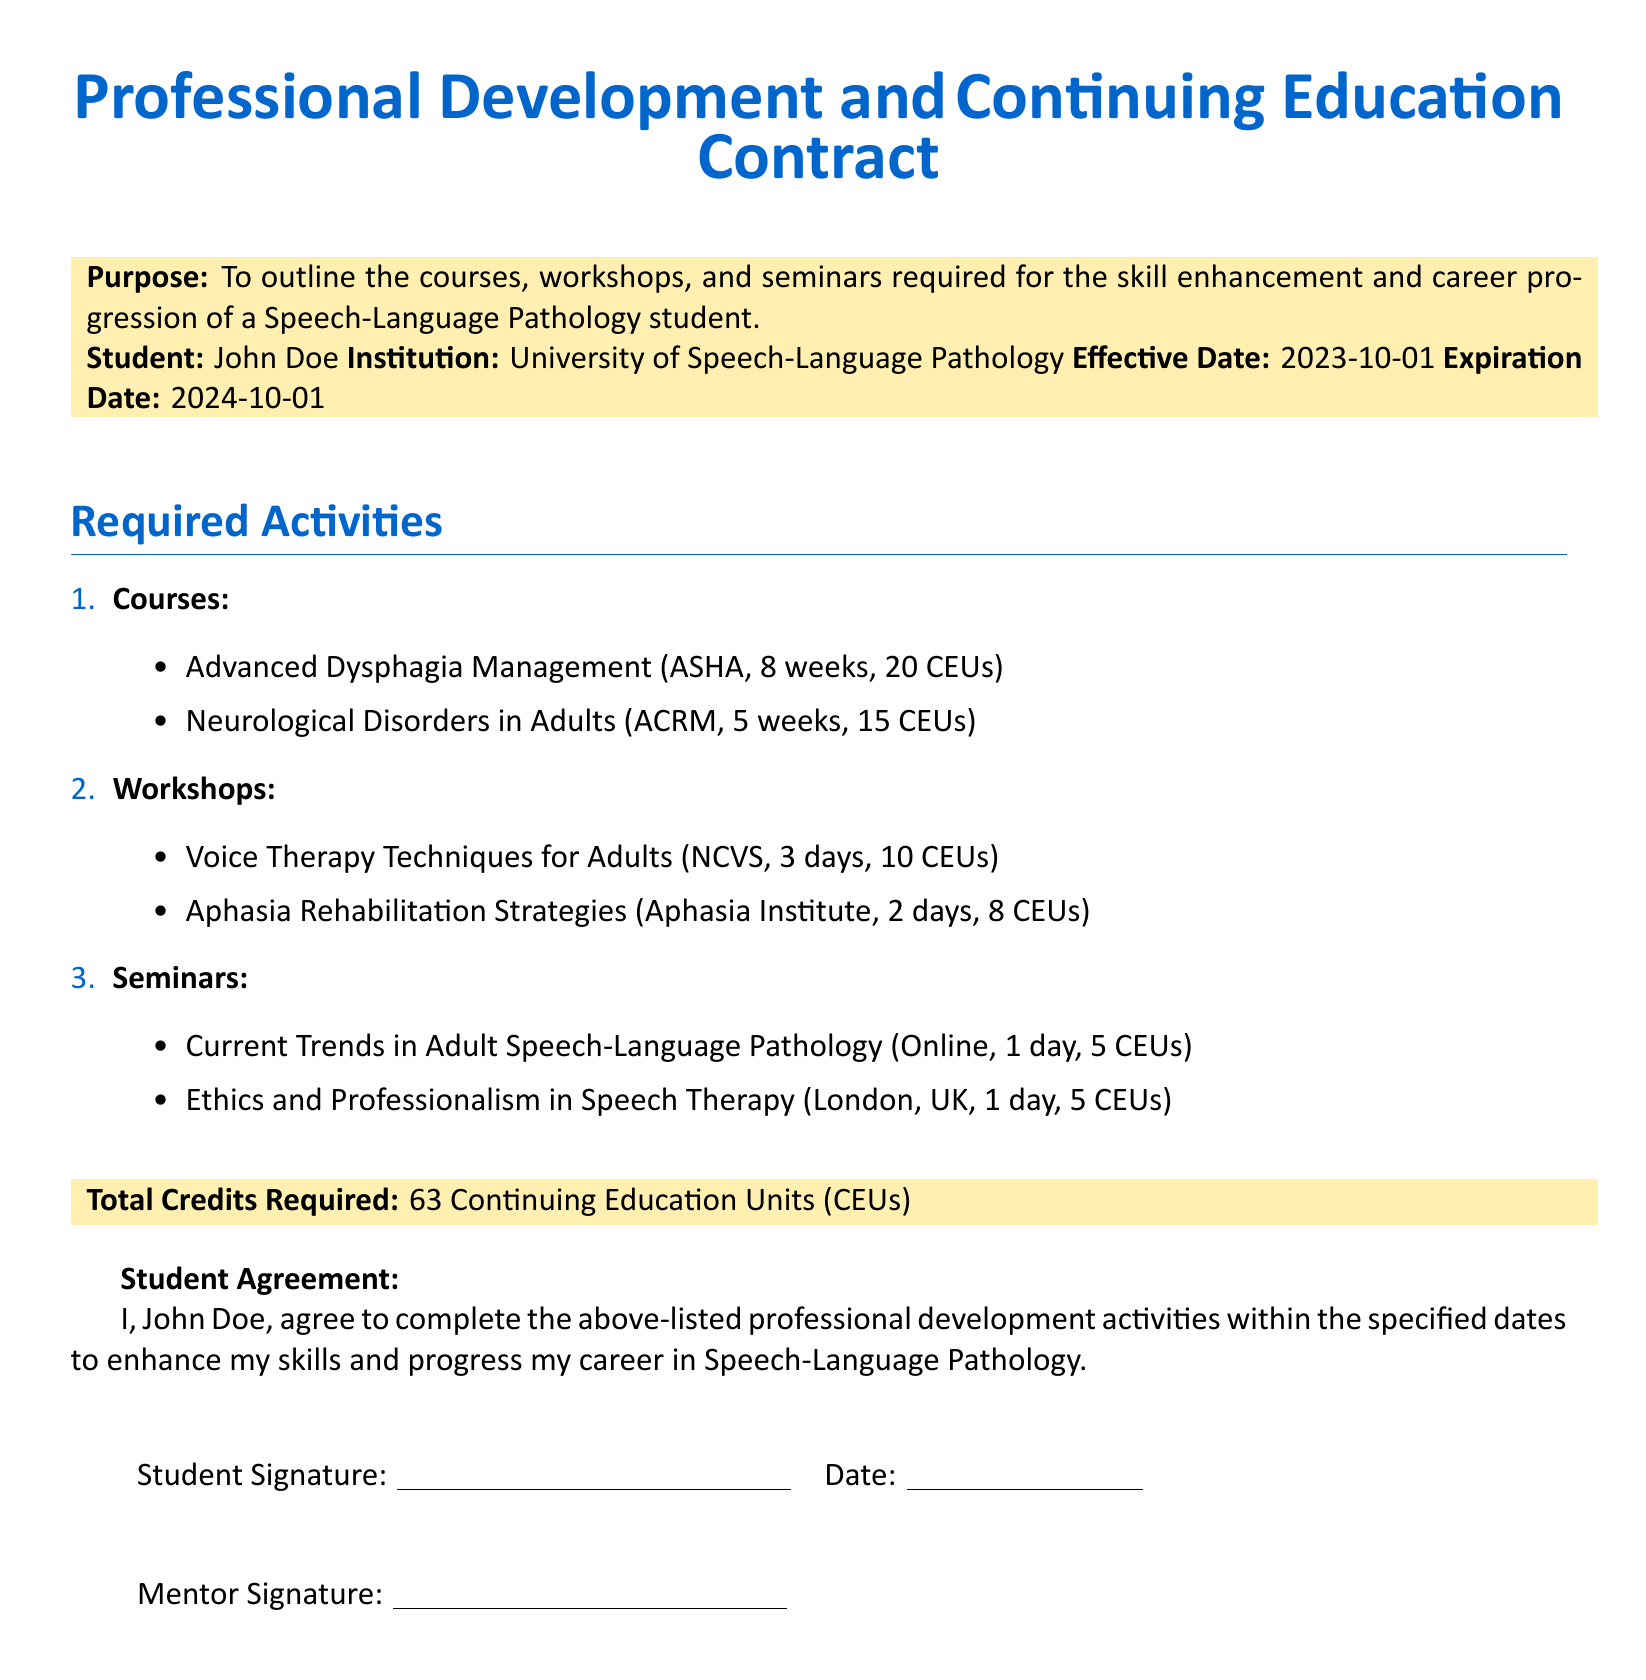What is the purpose of the document? The purpose of the document is outlined in the Purpose section, specifying it is to detail courses, workshops, and seminars for skill enhancement.
Answer: To outline the courses, workshops, and seminars required for the skill enhancement and career progression of a Speech-Language Pathology student Who is the student named in the contract? The name of the student is specified in the Student field.
Answer: John Doe What is the expiration date of the contract? The expiration date is found in the Expiration Date section.
Answer: 2024-10-01 How many Continuing Education Units (CEUs) are required? The total required CEUs are listed in the Total Credits Required section.
Answer: 63 Continuing Education Units (CEUs) What course is offered for Advanced Dysphagia Management? The specific course title is under the Courses section, which includes the name of the course and its details.
Answer: Advanced Dysphagia Management How long is the Neurological Disorders in Adults course? The duration of the course is provided in the Courses section.
Answer: 5 weeks How many CEUs does the Voice Therapy Techniques for Adults workshop provide? The CEUs for the workshop are noted under the Workshops section.
Answer: 10 CEUs What is the title of the seminar on Ethics? The title of the seminar is available in the Seminars section, specifying the focus of the seminar.
Answer: Ethics and Professionalism in Speech Therapy What is the effective date of the contract? The effective date is detailed in the Effective Date section.
Answer: 2023-10-01 